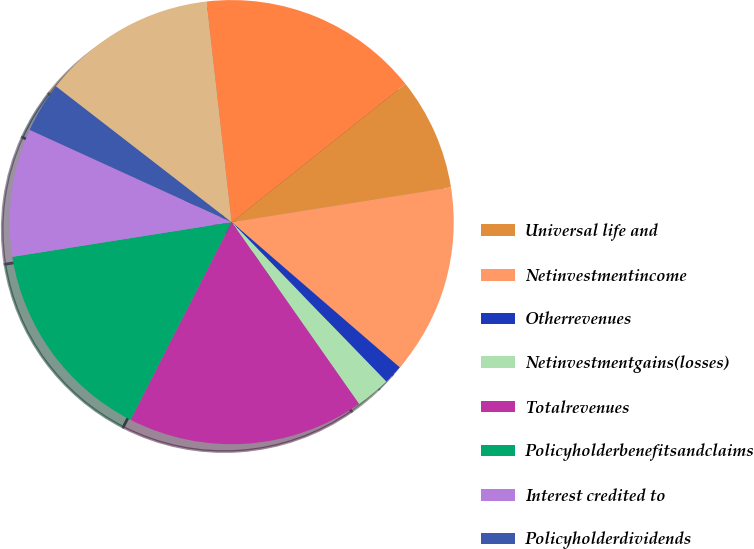Convert chart. <chart><loc_0><loc_0><loc_500><loc_500><pie_chart><fcel>Universal life and<fcel>Netinvestmentincome<fcel>Otherrevenues<fcel>Netinvestmentgains(losses)<fcel>Totalrevenues<fcel>Policyholderbenefitsandclaims<fcel>Interest credited to<fcel>Policyholderdividends<fcel>Otherexpenses<fcel>Totalexpenses<nl><fcel>8.19%<fcel>13.85%<fcel>1.4%<fcel>2.53%<fcel>17.25%<fcel>14.98%<fcel>9.32%<fcel>3.66%<fcel>12.72%<fcel>16.11%<nl></chart> 